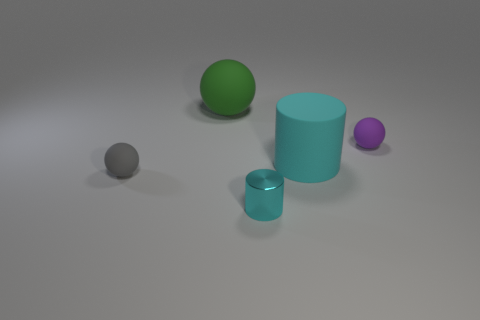What number of objects are tiny cylinders that are in front of the large rubber sphere or brown matte cylinders?
Keep it short and to the point. 1. The matte object that is left of the rubber cylinder and behind the tiny gray ball has what shape?
Make the answer very short. Sphere. Is there any other thing that has the same size as the gray matte thing?
Give a very brief answer. Yes. The cyan cylinder that is the same material as the tiny gray sphere is what size?
Provide a short and direct response. Large. How many things are small objects that are behind the gray matte ball or cyan objects that are in front of the gray object?
Provide a short and direct response. 2. Does the thing that is on the right side of the cyan matte cylinder have the same size as the small metallic object?
Provide a short and direct response. Yes. The big thing right of the green object is what color?
Your response must be concise. Cyan. What color is the large rubber object that is the same shape as the cyan shiny object?
Ensure brevity in your answer.  Cyan. There is a tiny object left of the large green rubber object that is behind the cyan rubber thing; how many large cylinders are to the right of it?
Offer a very short reply. 1. Is there anything else that has the same material as the big cyan thing?
Your answer should be compact. Yes. 